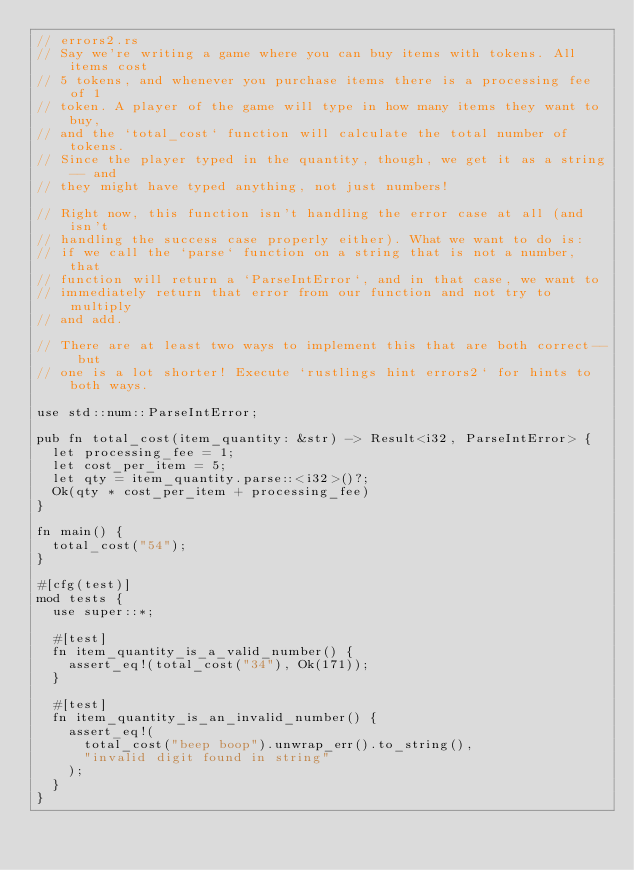<code> <loc_0><loc_0><loc_500><loc_500><_Rust_>// errors2.rs
// Say we're writing a game where you can buy items with tokens. All items cost
// 5 tokens, and whenever you purchase items there is a processing fee of 1
// token. A player of the game will type in how many items they want to buy,
// and the `total_cost` function will calculate the total number of tokens.
// Since the player typed in the quantity, though, we get it as a string-- and
// they might have typed anything, not just numbers!

// Right now, this function isn't handling the error case at all (and isn't
// handling the success case properly either). What we want to do is:
// if we call the `parse` function on a string that is not a number, that
// function will return a `ParseIntError`, and in that case, we want to
// immediately return that error from our function and not try to multiply
// and add.

// There are at least two ways to implement this that are both correct-- but
// one is a lot shorter! Execute `rustlings hint errors2` for hints to both ways.

use std::num::ParseIntError;

pub fn total_cost(item_quantity: &str) -> Result<i32, ParseIntError> {
  let processing_fee = 1;
  let cost_per_item = 5;
  let qty = item_quantity.parse::<i32>()?;
  Ok(qty * cost_per_item + processing_fee)
}

fn main() {
  total_cost("54");
}

#[cfg(test)]
mod tests {
  use super::*;

  #[test]
  fn item_quantity_is_a_valid_number() {
    assert_eq!(total_cost("34"), Ok(171));
  }

  #[test]
  fn item_quantity_is_an_invalid_number() {
    assert_eq!(
      total_cost("beep boop").unwrap_err().to_string(),
      "invalid digit found in string"
    );
  }
}
</code> 